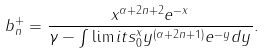<formula> <loc_0><loc_0><loc_500><loc_500>b _ { n } ^ { + } = \frac { x ^ { \alpha + 2 n + 2 } e ^ { - x } } { \gamma - \int \lim i t s _ { 0 } ^ { x } y ^ { ( \alpha + 2 n + 1 ) } e ^ { - y } d y } .</formula> 